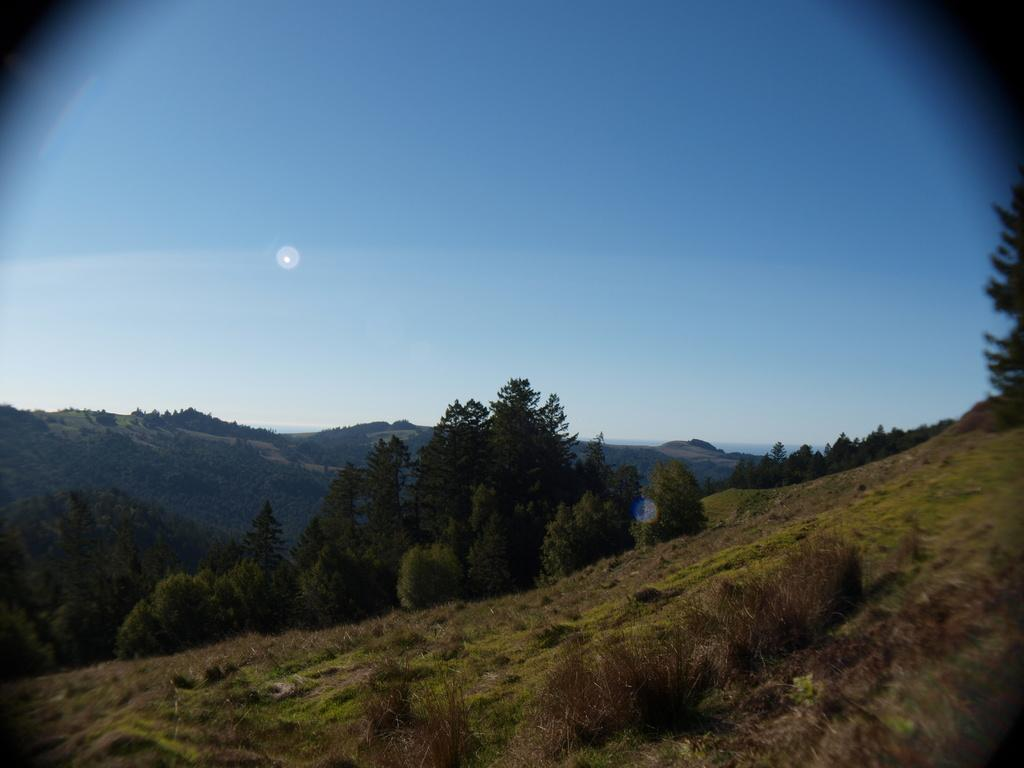What type of vegetation can be seen in the image? There are trees and plants in the image. What geographical features are present at the bottom of the image? There are hills at the bottom of the image. What is visible at the top of the image? The sky is visible at the top of the image. How many girls are holding spoons in the basin in the image? There are no girls, spoons, or basins present in the image. 